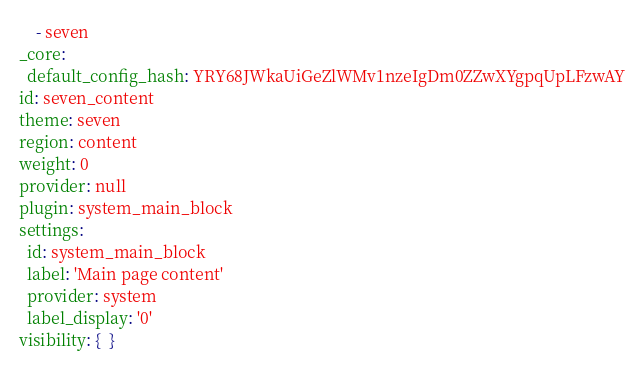Convert code to text. <code><loc_0><loc_0><loc_500><loc_500><_YAML_>    - seven
_core:
  default_config_hash: YRY68JWkaUiGeZlWMv1nzeIgDm0ZZwXYgpqUpLFzwAY
id: seven_content
theme: seven
region: content
weight: 0
provider: null
plugin: system_main_block
settings:
  id: system_main_block
  label: 'Main page content'
  provider: system
  label_display: '0'
visibility: {  }
</code> 